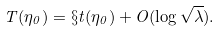Convert formula to latex. <formula><loc_0><loc_0><loc_500><loc_500>T ( \eta _ { 0 } ) = \S t ( \eta _ { 0 } ) + O ( \log \sqrt { \lambda } ) .</formula> 